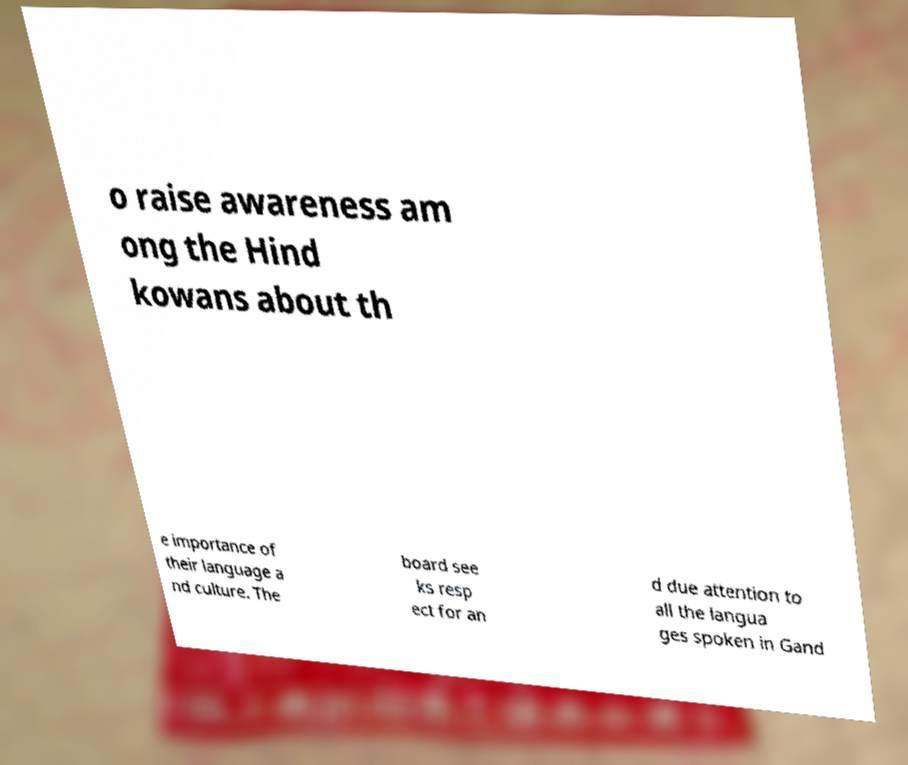I need the written content from this picture converted into text. Can you do that? o raise awareness am ong the Hind kowans about th e importance of their language a nd culture. The board see ks resp ect for an d due attention to all the langua ges spoken in Gand 